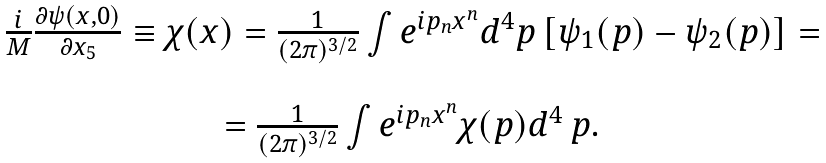Convert formula to latex. <formula><loc_0><loc_0><loc_500><loc_500>\begin{array} { c } \frac { i } { M } \frac { \partial \psi ( x , 0 ) } { \partial x _ { 5 } } \equiv \chi ( x ) = \frac { 1 } { ( 2 \pi ) ^ { 3 / 2 } } \int e ^ { i p _ { n } x ^ { n } } d ^ { 4 } p \left [ \psi _ { 1 } ( p ) - \psi _ { 2 } ( p ) \right ] = \\ \\ = \frac { 1 } { ( 2 \pi ) ^ { 3 / 2 } } \int e ^ { i p _ { n } x ^ { n } } \chi ( p ) d ^ { 4 } \, p . \\ \end{array}</formula> 